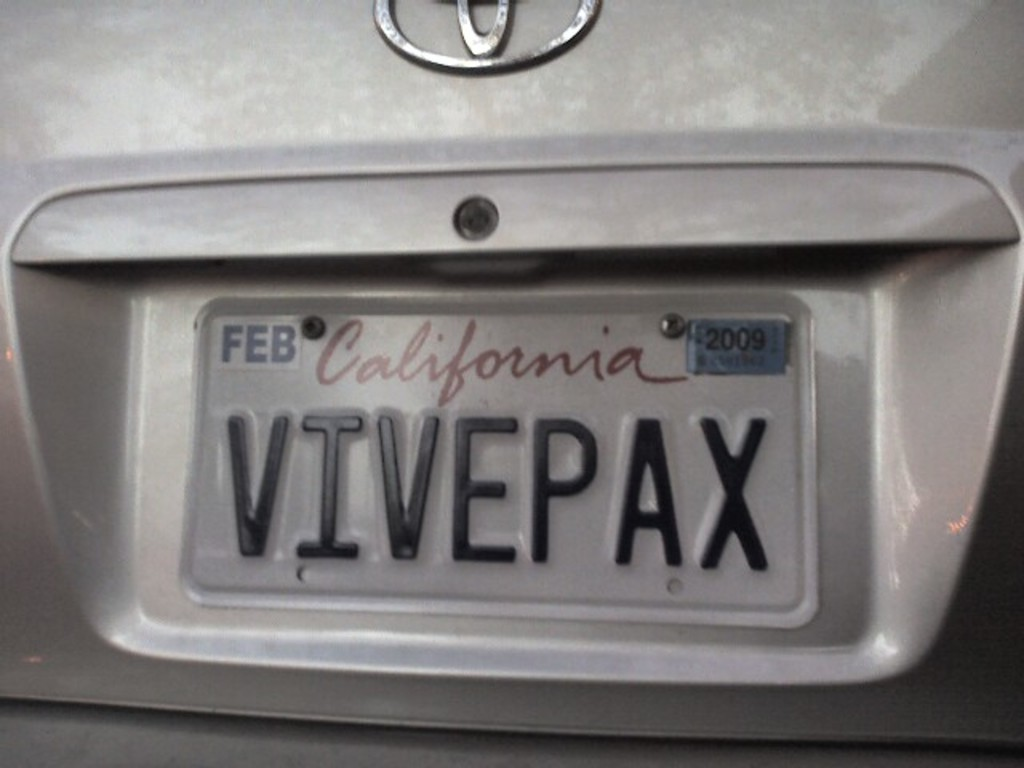How does the registration indicator affect the legal status of this vehicle? Driving with a registration that expired in February 2009 means the vehicle is not legally compliant, which can lead to fines or penalties if the owner is caught driving or parking it on public roads. 